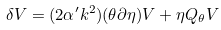<formula> <loc_0><loc_0><loc_500><loc_500>\delta V = ( 2 \alpha ^ { \prime } k ^ { 2 } ) ( \theta \partial \eta ) V + \eta Q _ { \theta } V</formula> 